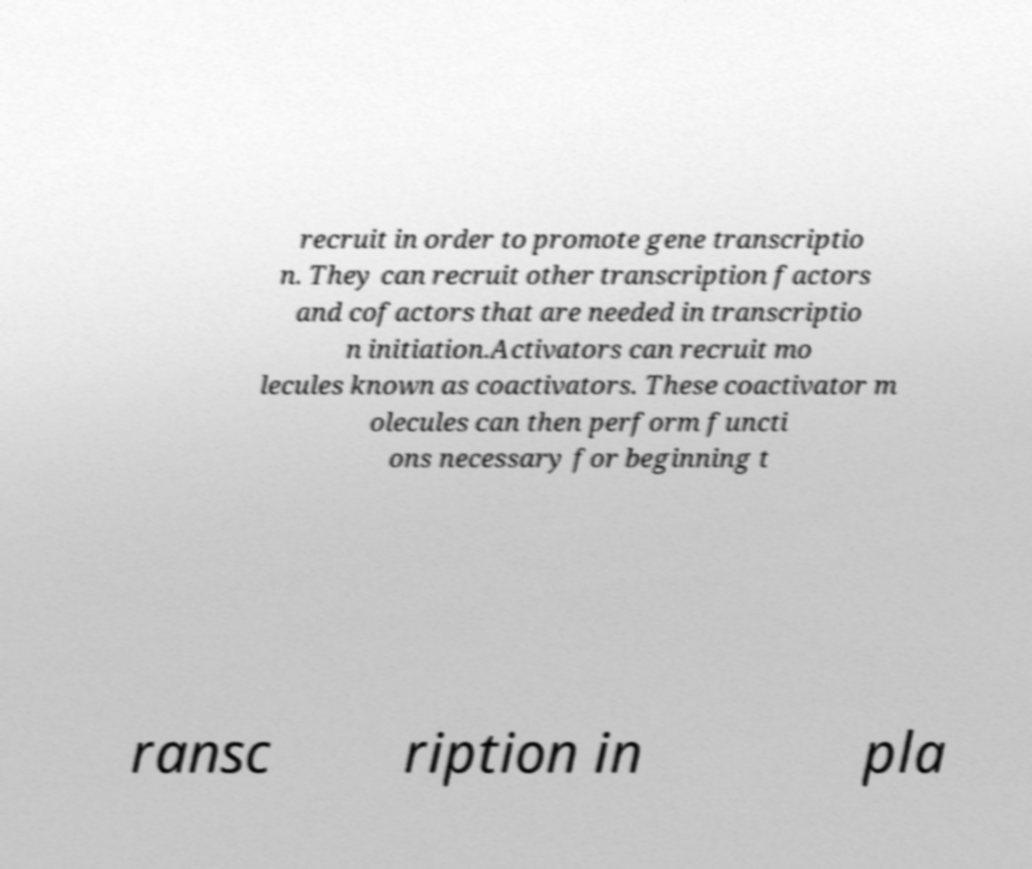Could you extract and type out the text from this image? recruit in order to promote gene transcriptio n. They can recruit other transcription factors and cofactors that are needed in transcriptio n initiation.Activators can recruit mo lecules known as coactivators. These coactivator m olecules can then perform functi ons necessary for beginning t ransc ription in pla 